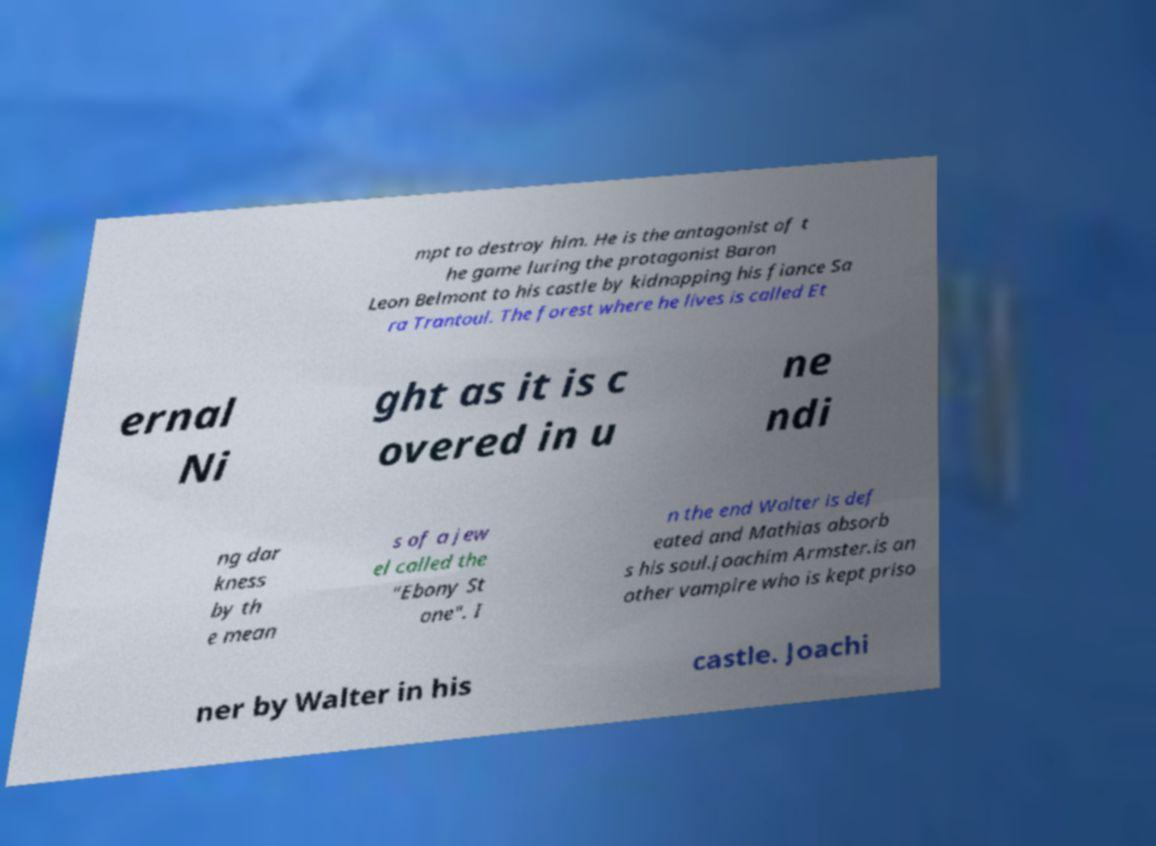Can you read and provide the text displayed in the image?This photo seems to have some interesting text. Can you extract and type it out for me? mpt to destroy him. He is the antagonist of t he game luring the protagonist Baron Leon Belmont to his castle by kidnapping his fiance Sa ra Trantoul. The forest where he lives is called Et ernal Ni ght as it is c overed in u ne ndi ng dar kness by th e mean s of a jew el called the "Ebony St one". I n the end Walter is def eated and Mathias absorb s his soul.Joachim Armster.is an other vampire who is kept priso ner by Walter in his castle. Joachi 